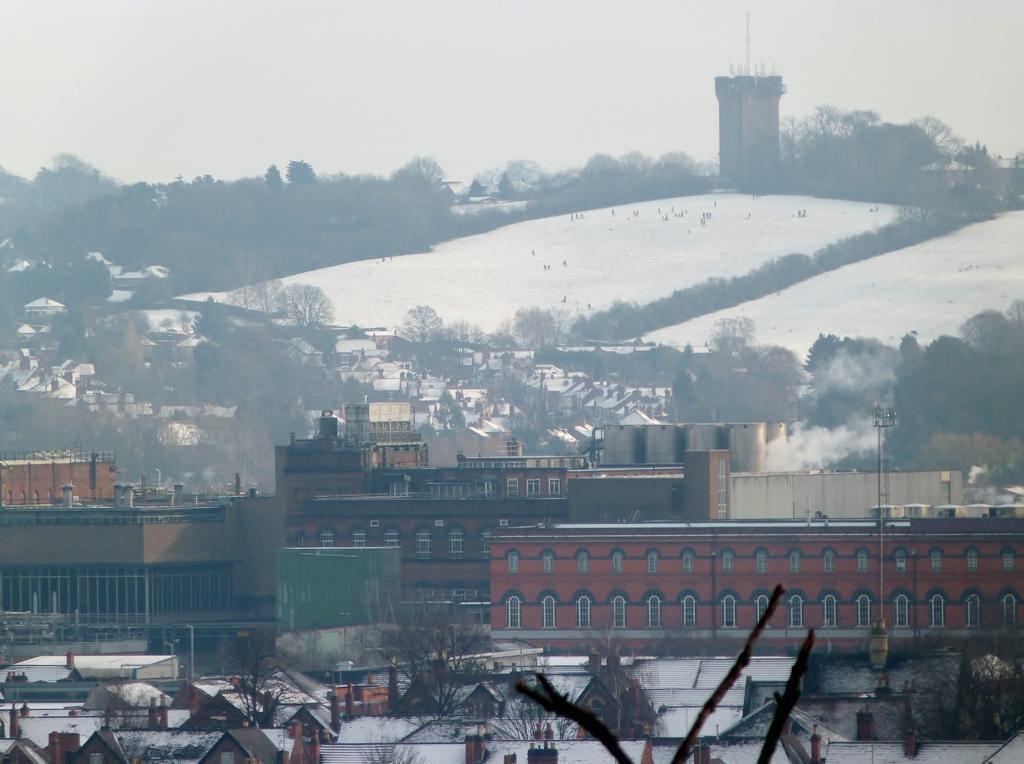Please provide a concise description of this image. In the center of the image there are buildings and sheds. In the background there is snow, trees, poles, tower and sky. 